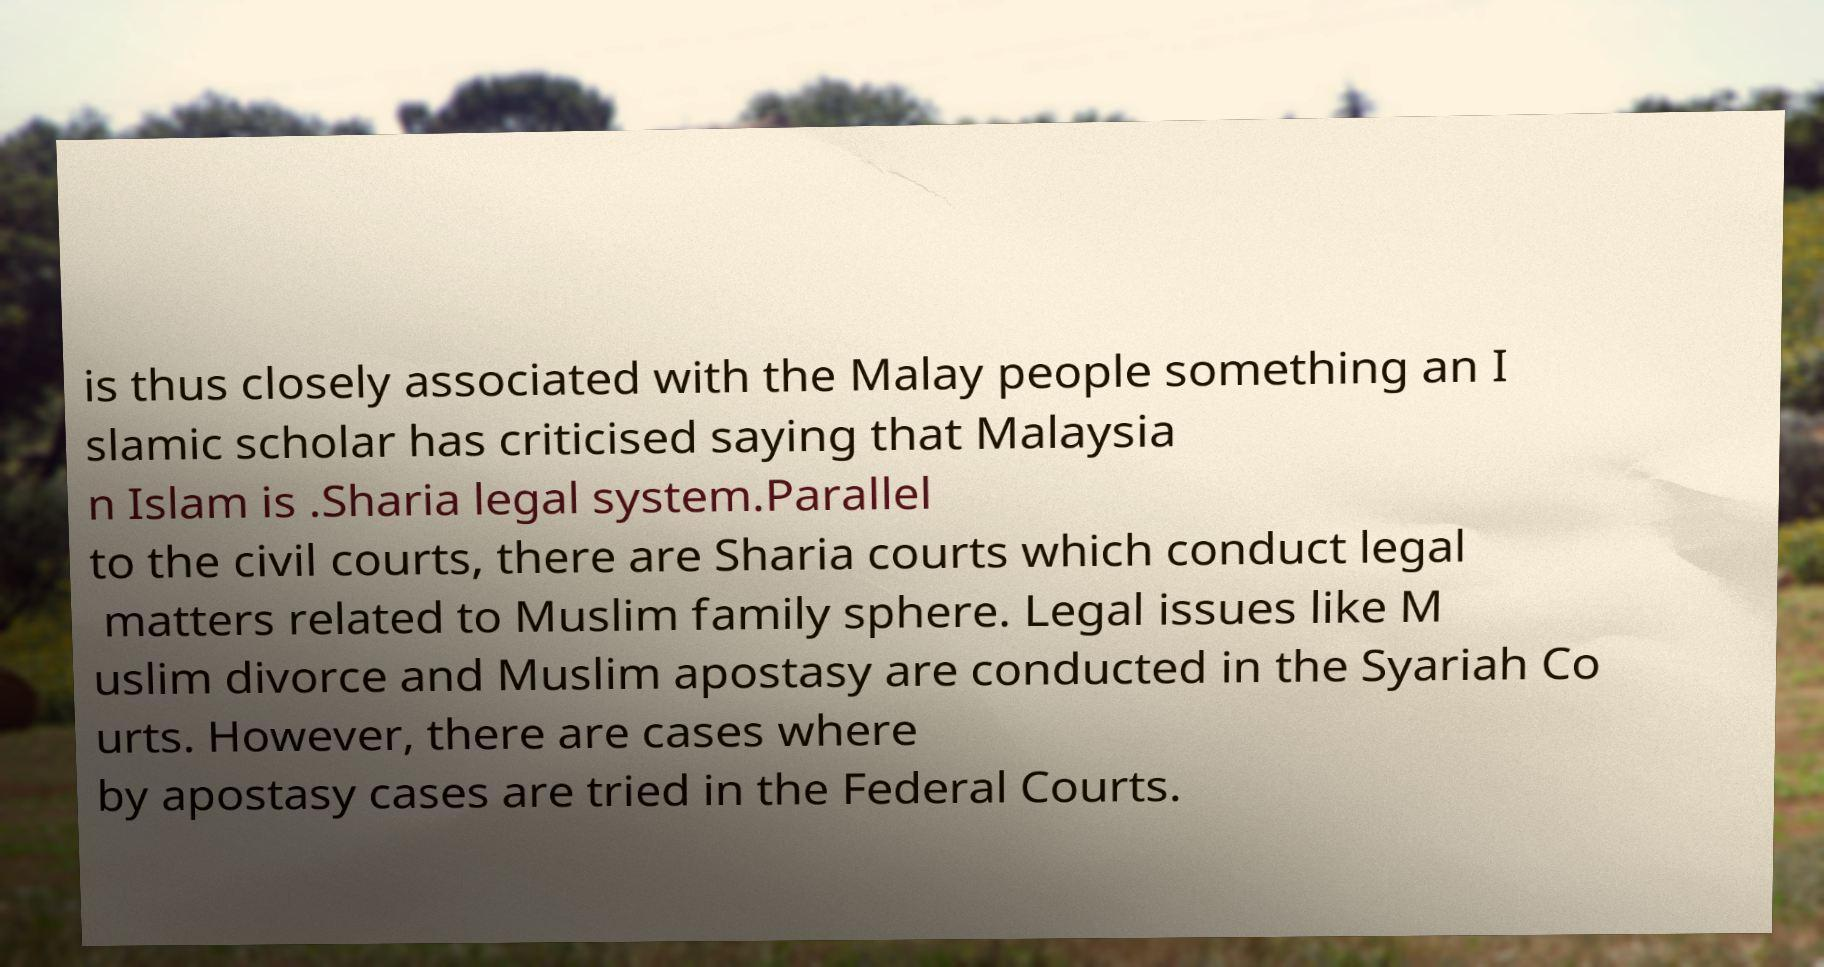Please identify and transcribe the text found in this image. is thus closely associated with the Malay people something an I slamic scholar has criticised saying that Malaysia n Islam is .Sharia legal system.Parallel to the civil courts, there are Sharia courts which conduct legal matters related to Muslim family sphere. Legal issues like M uslim divorce and Muslim apostasy are conducted in the Syariah Co urts. However, there are cases where by apostasy cases are tried in the Federal Courts. 